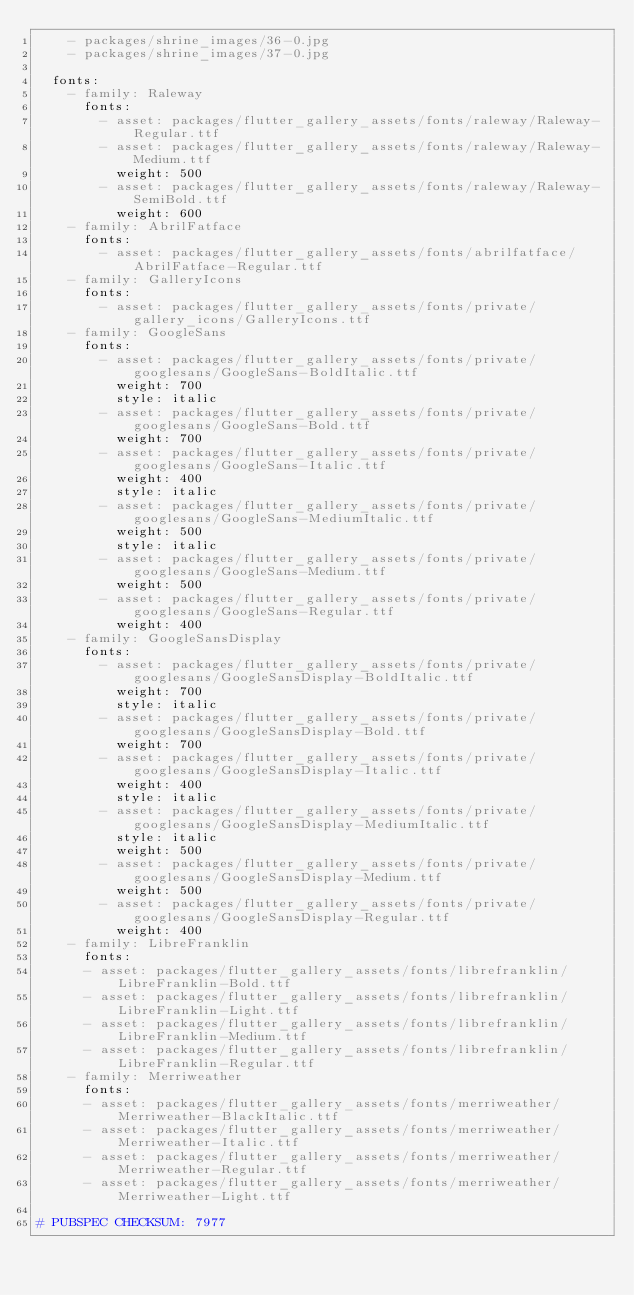<code> <loc_0><loc_0><loc_500><loc_500><_YAML_>    - packages/shrine_images/36-0.jpg
    - packages/shrine_images/37-0.jpg

  fonts:
    - family: Raleway
      fonts:
        - asset: packages/flutter_gallery_assets/fonts/raleway/Raleway-Regular.ttf
        - asset: packages/flutter_gallery_assets/fonts/raleway/Raleway-Medium.ttf
          weight: 500
        - asset: packages/flutter_gallery_assets/fonts/raleway/Raleway-SemiBold.ttf
          weight: 600
    - family: AbrilFatface
      fonts:
        - asset: packages/flutter_gallery_assets/fonts/abrilfatface/AbrilFatface-Regular.ttf
    - family: GalleryIcons
      fonts:
        - asset: packages/flutter_gallery_assets/fonts/private/gallery_icons/GalleryIcons.ttf
    - family: GoogleSans
      fonts:
        - asset: packages/flutter_gallery_assets/fonts/private/googlesans/GoogleSans-BoldItalic.ttf
          weight: 700
          style: italic
        - asset: packages/flutter_gallery_assets/fonts/private/googlesans/GoogleSans-Bold.ttf
          weight: 700
        - asset: packages/flutter_gallery_assets/fonts/private/googlesans/GoogleSans-Italic.ttf
          weight: 400
          style: italic
        - asset: packages/flutter_gallery_assets/fonts/private/googlesans/GoogleSans-MediumItalic.ttf
          weight: 500
          style: italic
        - asset: packages/flutter_gallery_assets/fonts/private/googlesans/GoogleSans-Medium.ttf
          weight: 500
        - asset: packages/flutter_gallery_assets/fonts/private/googlesans/GoogleSans-Regular.ttf
          weight: 400
    - family: GoogleSansDisplay
      fonts:
        - asset: packages/flutter_gallery_assets/fonts/private/googlesans/GoogleSansDisplay-BoldItalic.ttf
          weight: 700
          style: italic
        - asset: packages/flutter_gallery_assets/fonts/private/googlesans/GoogleSansDisplay-Bold.ttf
          weight: 700
        - asset: packages/flutter_gallery_assets/fonts/private/googlesans/GoogleSansDisplay-Italic.ttf
          weight: 400
          style: italic
        - asset: packages/flutter_gallery_assets/fonts/private/googlesans/GoogleSansDisplay-MediumItalic.ttf
          style: italic
          weight: 500
        - asset: packages/flutter_gallery_assets/fonts/private/googlesans/GoogleSansDisplay-Medium.ttf
          weight: 500
        - asset: packages/flutter_gallery_assets/fonts/private/googlesans/GoogleSansDisplay-Regular.ttf
          weight: 400
    - family: LibreFranklin
      fonts:
      - asset: packages/flutter_gallery_assets/fonts/librefranklin/LibreFranklin-Bold.ttf
      - asset: packages/flutter_gallery_assets/fonts/librefranklin/LibreFranklin-Light.ttf
      - asset: packages/flutter_gallery_assets/fonts/librefranklin/LibreFranklin-Medium.ttf
      - asset: packages/flutter_gallery_assets/fonts/librefranklin/LibreFranklin-Regular.ttf
    - family: Merriweather
      fonts:
      - asset: packages/flutter_gallery_assets/fonts/merriweather/Merriweather-BlackItalic.ttf
      - asset: packages/flutter_gallery_assets/fonts/merriweather/Merriweather-Italic.ttf
      - asset: packages/flutter_gallery_assets/fonts/merriweather/Merriweather-Regular.ttf
      - asset: packages/flutter_gallery_assets/fonts/merriweather/Merriweather-Light.ttf

# PUBSPEC CHECKSUM: 7977
</code> 